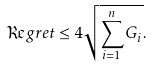<formula> <loc_0><loc_0><loc_500><loc_500>\Re g r e t \leq 4 \sqrt { \sum _ { i = 1 } ^ { n } G _ { i } } .</formula> 